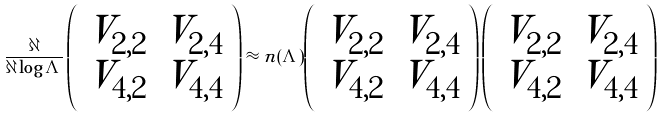<formula> <loc_0><loc_0><loc_500><loc_500>\frac { \partial } { \partial \log \Lambda } \left ( \begin{array} { c c } V _ { 2 , 2 } & V _ { 2 , 4 } \\ V _ { 4 , 2 } & V _ { 4 , 4 } \end{array} \right ) \approx n ( \Lambda ) \left ( \begin{array} { c c } V _ { 2 , 2 } & V _ { 2 , 4 } \\ V _ { 4 , 2 } & V _ { 4 , 4 } \end{array} \right ) \left ( \begin{array} { c c } V _ { 2 , 2 } & V _ { 2 , 4 } \\ V _ { 4 , 2 } & V _ { 4 , 4 } \end{array} \right )</formula> 